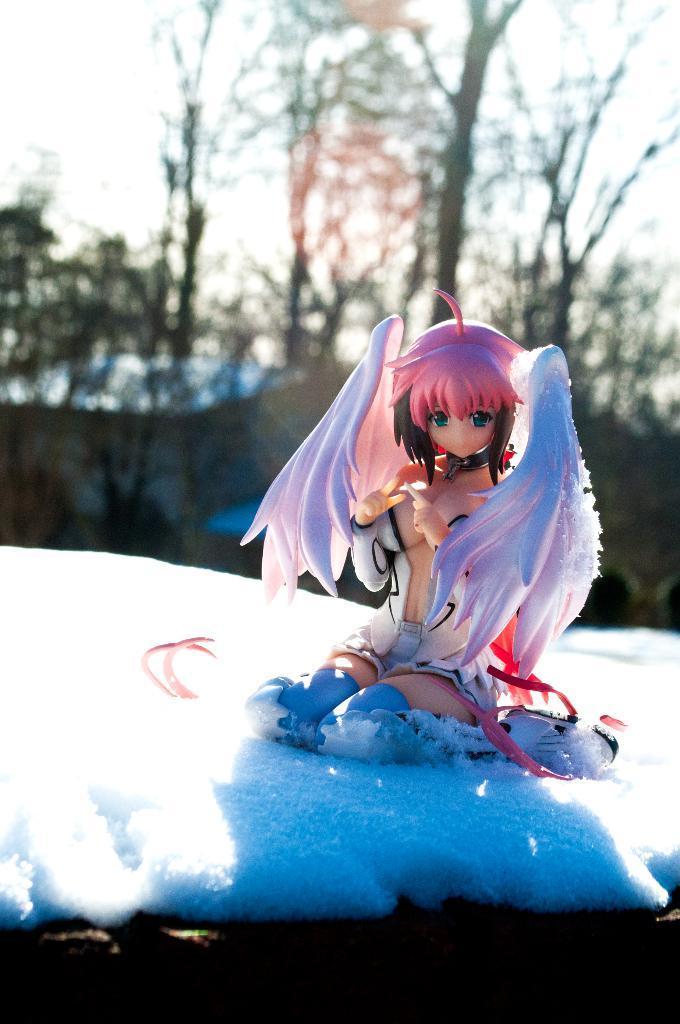Please provide a concise description of this image. In the image I can see a doll which is on the snow and behind there are some trees. 